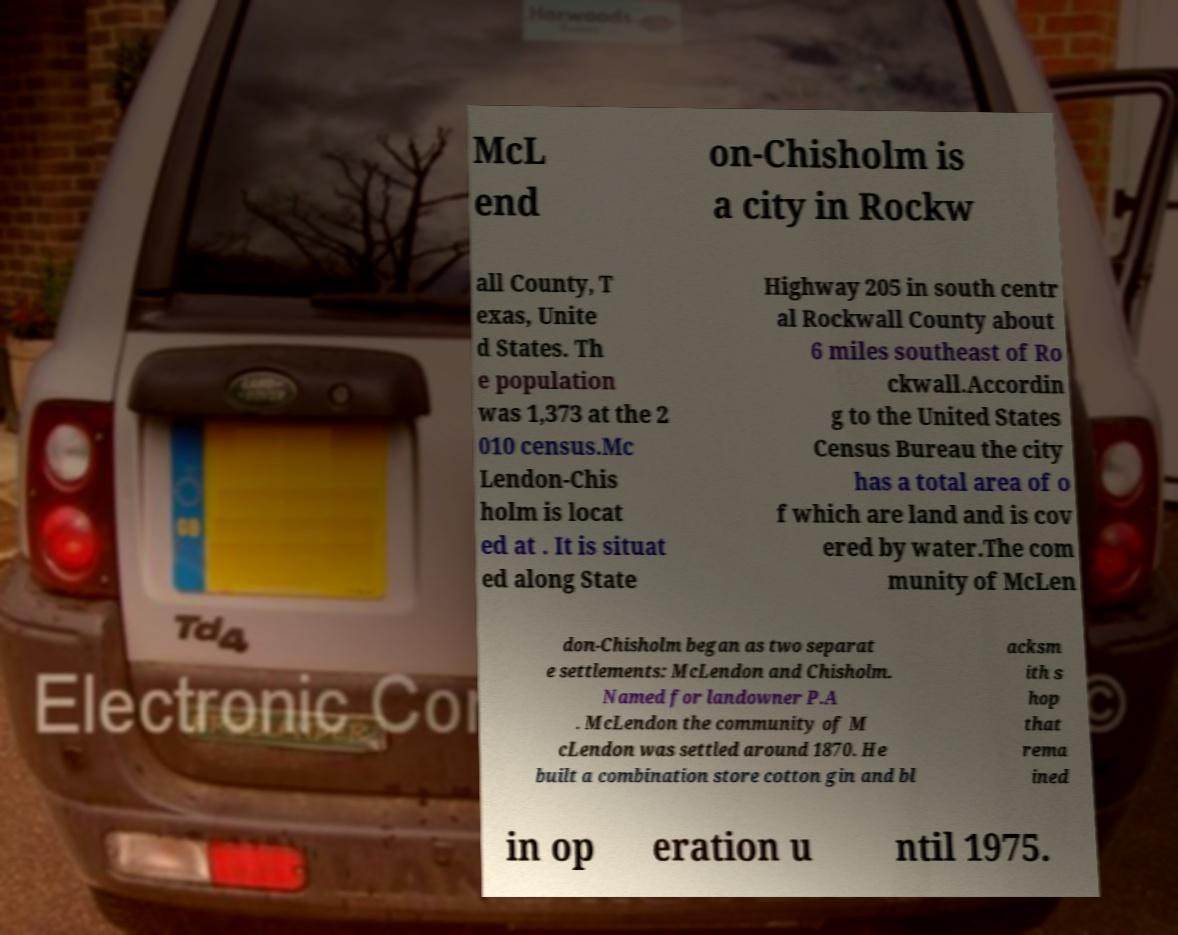Please read and relay the text visible in this image. What does it say? McL end on-Chisholm is a city in Rockw all County, T exas, Unite d States. Th e population was 1,373 at the 2 010 census.Mc Lendon-Chis holm is locat ed at . It is situat ed along State Highway 205 in south centr al Rockwall County about 6 miles southeast of Ro ckwall.Accordin g to the United States Census Bureau the city has a total area of o f which are land and is cov ered by water.The com munity of McLen don-Chisholm began as two separat e settlements: McLendon and Chisholm. Named for landowner P.A . McLendon the community of M cLendon was settled around 1870. He built a combination store cotton gin and bl acksm ith s hop that rema ined in op eration u ntil 1975. 